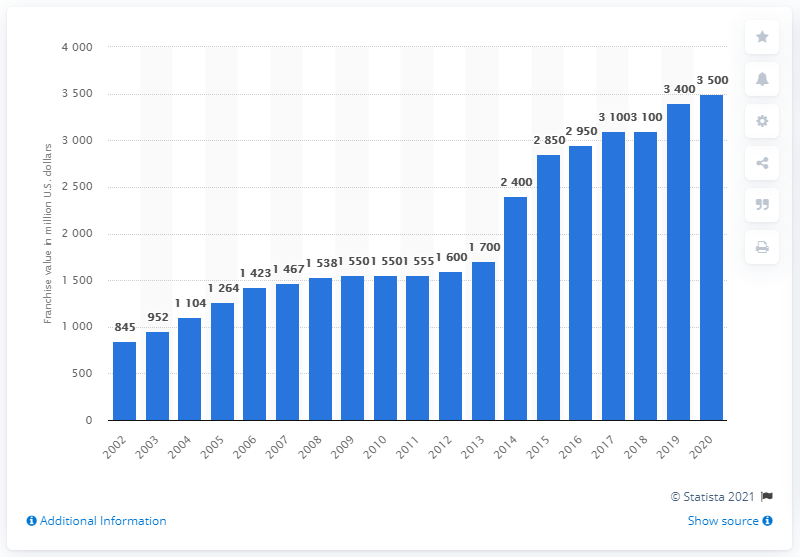List a handful of essential elements in this visual. The franchise value of the Washington Football Team in 2020 was 3,500. 